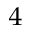<formula> <loc_0><loc_0><loc_500><loc_500>^ { 4 }</formula> 